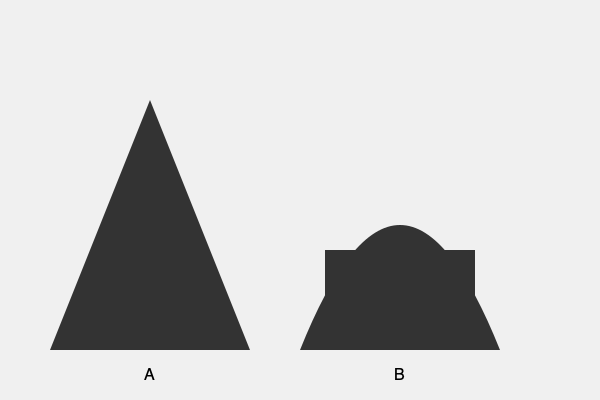Analyze the silhouettes of the two religious structures shown above. How do their architectural styles reflect different cultural and environmental adaptations, and what can this tell us about the societies that built them? To answer this question, we need to examine the architectural features of both structures and consider their cultural and environmental implications:

1. Structure A:
   - Pyramidal shape with a triangular profile
   - Steep sides converging to a point
   - Resembles ancient Egyptian pyramids or Mesoamerican step pyramids

2. Structure B:
   - Domed top with a curved profile
   - Rectangular base
   - Resembles Islamic mosques or Byzantine churches

Step-by-step analysis:

1. Cultural adaptations:
   a) Structure A:
      - Pyramidal shape often associated with ancient Egyptian or Mesoamerican cultures
      - Symbolizes a connection between earth and sky, reflecting belief in ascension to the heavens
      - Monumental scale suggests a society with centralized power and ability to mobilize large labor forces

   b) Structure B:
      - Domed structure typical of Islamic or Byzantine architecture
      - Dome represents the vault of heaven in many cultures
      - Combination of dome and rectangular base suggests a more complex internal space, possibly for congregational worship

2. Environmental adaptations:
   a) Structure A:
      - Sloped sides effective for shedding rain and sand in arid climates
      - Solid, massive construction provides thermal mass for temperature regulation
      - Simple shape resistant to earthquakes and wind

   b) Structure B:
      - Dome shape efficient for dispersing rainwater in wetter climates
      - Curved top reduces snow accumulation in colder regions
      - Larger internal volume allows for better air circulation in hot climates

3. Societal implications:
   a) Structure A:
      - Suggests a society with strong central authority and religious hierarchy
      - Indicates advanced mathematical and engineering knowledge
      - Implies a culture focused on afterlife and monumental commemoration

   b) Structure B:
      - Reflects a society with developed architectural techniques for creating large interior spaces
      - Suggests a more communal approach to worship
      - Indicates cultural exchange and influence across regions (e.g., Byzantine to Islamic)

These architectural styles reveal different approaches to religious expression, environmental adaptation, and societal organization, reflecting the unique cultural contexts in which they were developed.
Answer: Pyramidal structure A suggests ancient Egyptian/Mesoamerican cultures with centralized power, while domed structure B indicates Islamic/Byzantine influence with communal worship. Both reflect cultural beliefs, environmental adaptations, and societal organization through their distinct architectural features. 